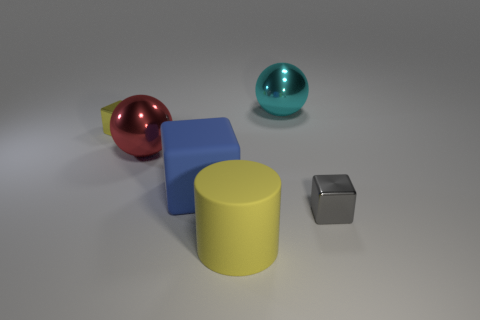There is a block that is the same size as the cyan metal ball; what is its material?
Offer a very short reply. Rubber. Is there a cylinder of the same color as the matte block?
Ensure brevity in your answer.  No. What is the shape of the metallic object that is in front of the yellow metal thing and on the right side of the big blue rubber object?
Provide a succinct answer. Cube. What number of blue cubes have the same material as the gray thing?
Give a very brief answer. 0. Is the number of red objects that are behind the red ball less than the number of big metal spheres in front of the tiny yellow block?
Your answer should be compact. Yes. There is a large ball that is in front of the tiny metallic thing behind the metallic object that is to the right of the large cyan metal ball; what is it made of?
Your answer should be very brief. Metal. How big is the thing that is in front of the large blue rubber cube and behind the cylinder?
Provide a succinct answer. Small. What number of cylinders are either tiny gray things or big cyan things?
Keep it short and to the point. 0. There is a cylinder that is the same size as the blue rubber cube; what is its color?
Offer a very short reply. Yellow. Is there anything else that is the same shape as the yellow matte object?
Ensure brevity in your answer.  No. 